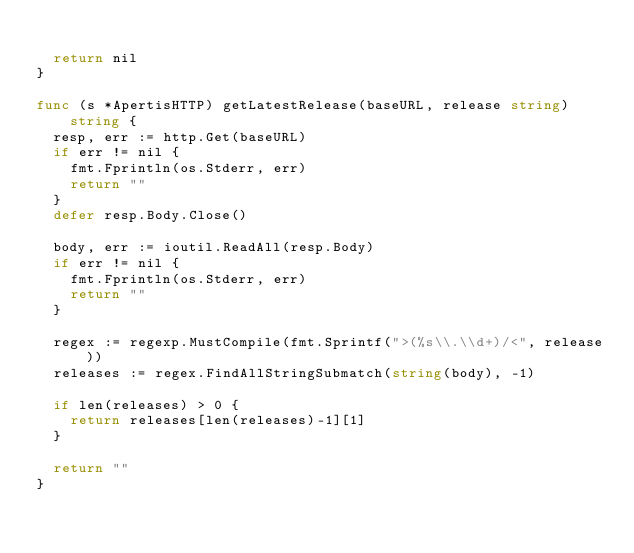Convert code to text. <code><loc_0><loc_0><loc_500><loc_500><_Go_>
	return nil
}

func (s *ApertisHTTP) getLatestRelease(baseURL, release string) string {
	resp, err := http.Get(baseURL)
	if err != nil {
		fmt.Fprintln(os.Stderr, err)
		return ""
	}
	defer resp.Body.Close()

	body, err := ioutil.ReadAll(resp.Body)
	if err != nil {
		fmt.Fprintln(os.Stderr, err)
		return ""
	}

	regex := regexp.MustCompile(fmt.Sprintf(">(%s\\.\\d+)/<", release))
	releases := regex.FindAllStringSubmatch(string(body), -1)

	if len(releases) > 0 {
		return releases[len(releases)-1][1]
	}

	return ""
}
</code> 